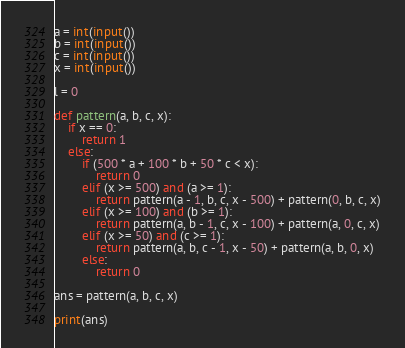Convert code to text. <code><loc_0><loc_0><loc_500><loc_500><_Python_>a = int(input())
b = int(input())
c = int(input())
x = int(input())
 
l = 0
 
def pattern(a, b, c, x):
	if x == 0:
		return 1
	else:
		if (500 * a + 100 * b + 50 * c < x):
			return 0
		elif (x >= 500) and (a >= 1):
			return pattern(a - 1, b, c, x - 500) + pattern(0, b, c, x)
		elif (x >= 100) and (b >= 1):
			return pattern(a, b - 1, c, x - 100) + pattern(a, 0, c, x)
		elif (x >= 50) and (c >= 1):
			return pattern(a, b, c - 1, x - 50) + pattern(a, b, 0, x)
		else:
			return 0
 
ans = pattern(a, b, c, x)
 
print(ans)</code> 